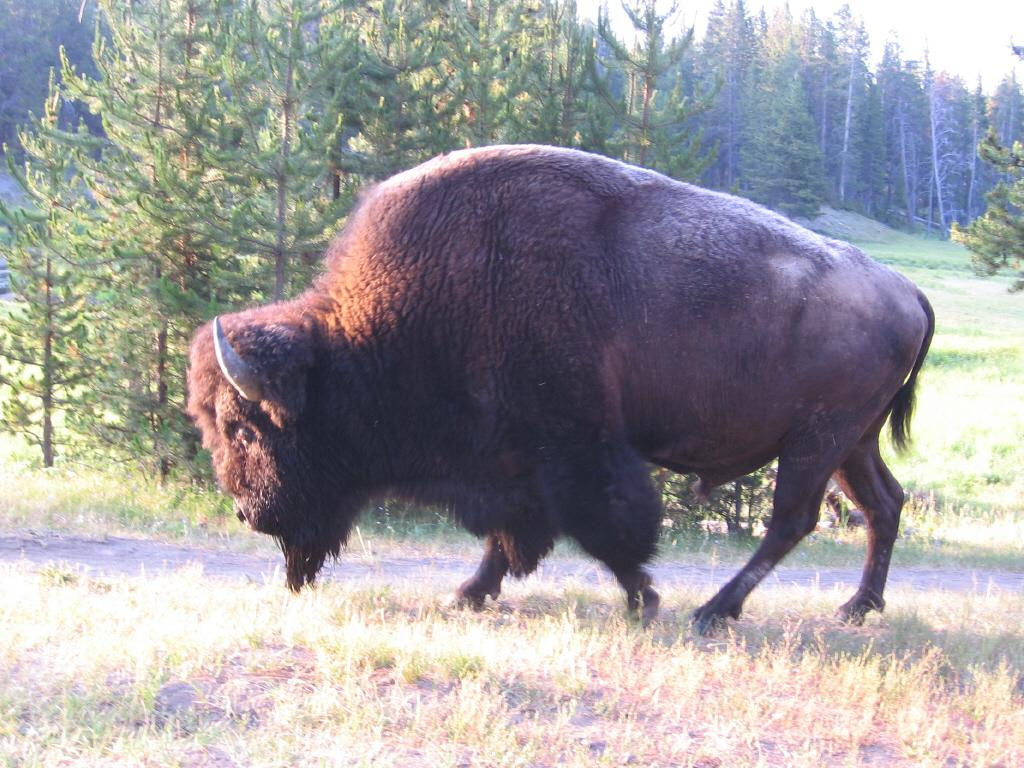What type of creature is in the image? There is an animal in the image. How is the animal positioned in the image? The animal is standing on the ground. What is the ground covered with? The ground is covered with grass. What can be seen in the distance in the image? There are trees visible in the background of the image. What is the tax rate for the animal in the image? There is no information about tax rates in the image, as it features an animal standing on grass with trees in the background. 